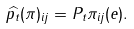<formula> <loc_0><loc_0><loc_500><loc_500>\widehat { p _ { t } } ( \pi ) _ { i j } = P _ { t } \pi _ { i j } ( e ) .</formula> 